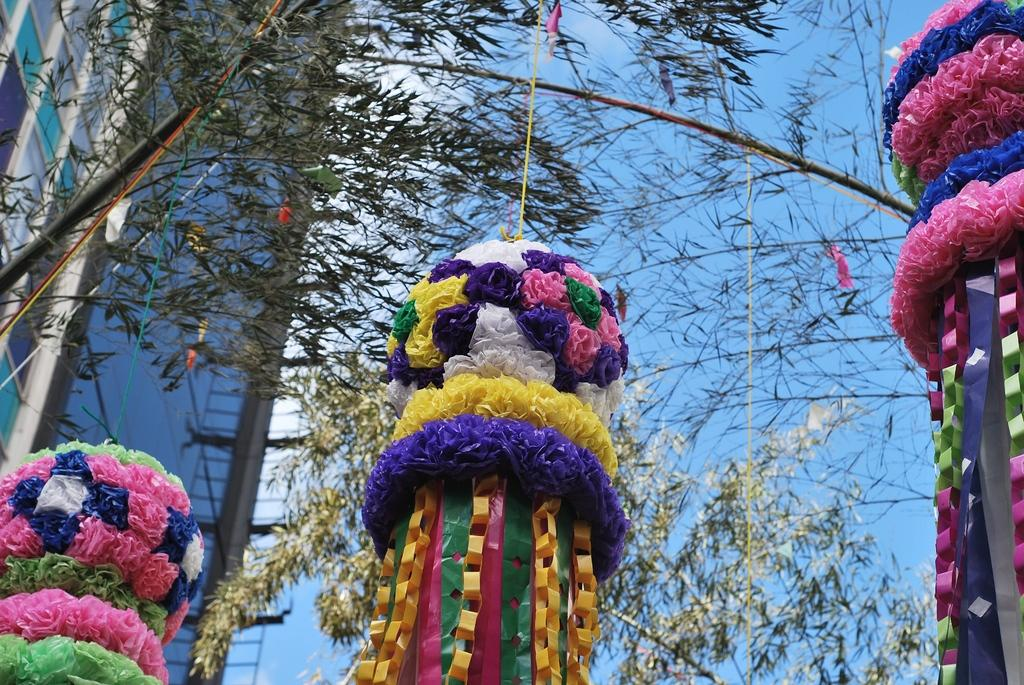What is attached to the tree in the image? There are decorative items tied to a tree in the image. What can be seen in the distance behind the tree? There is a building in the background of the image. What is visible in the sky in the image? The sky is visible in the background of the image. What type of pen is being used to draw on the canvas in the image? There is no pen or canvas present in the image; it features decorative items tied to a tree and a building in the background. 